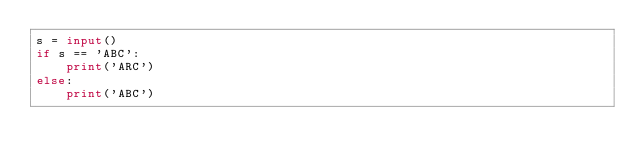Convert code to text. <code><loc_0><loc_0><loc_500><loc_500><_Python_>s = input()
if s == 'ABC':
    print('ARC')
else:
    print('ABC')</code> 